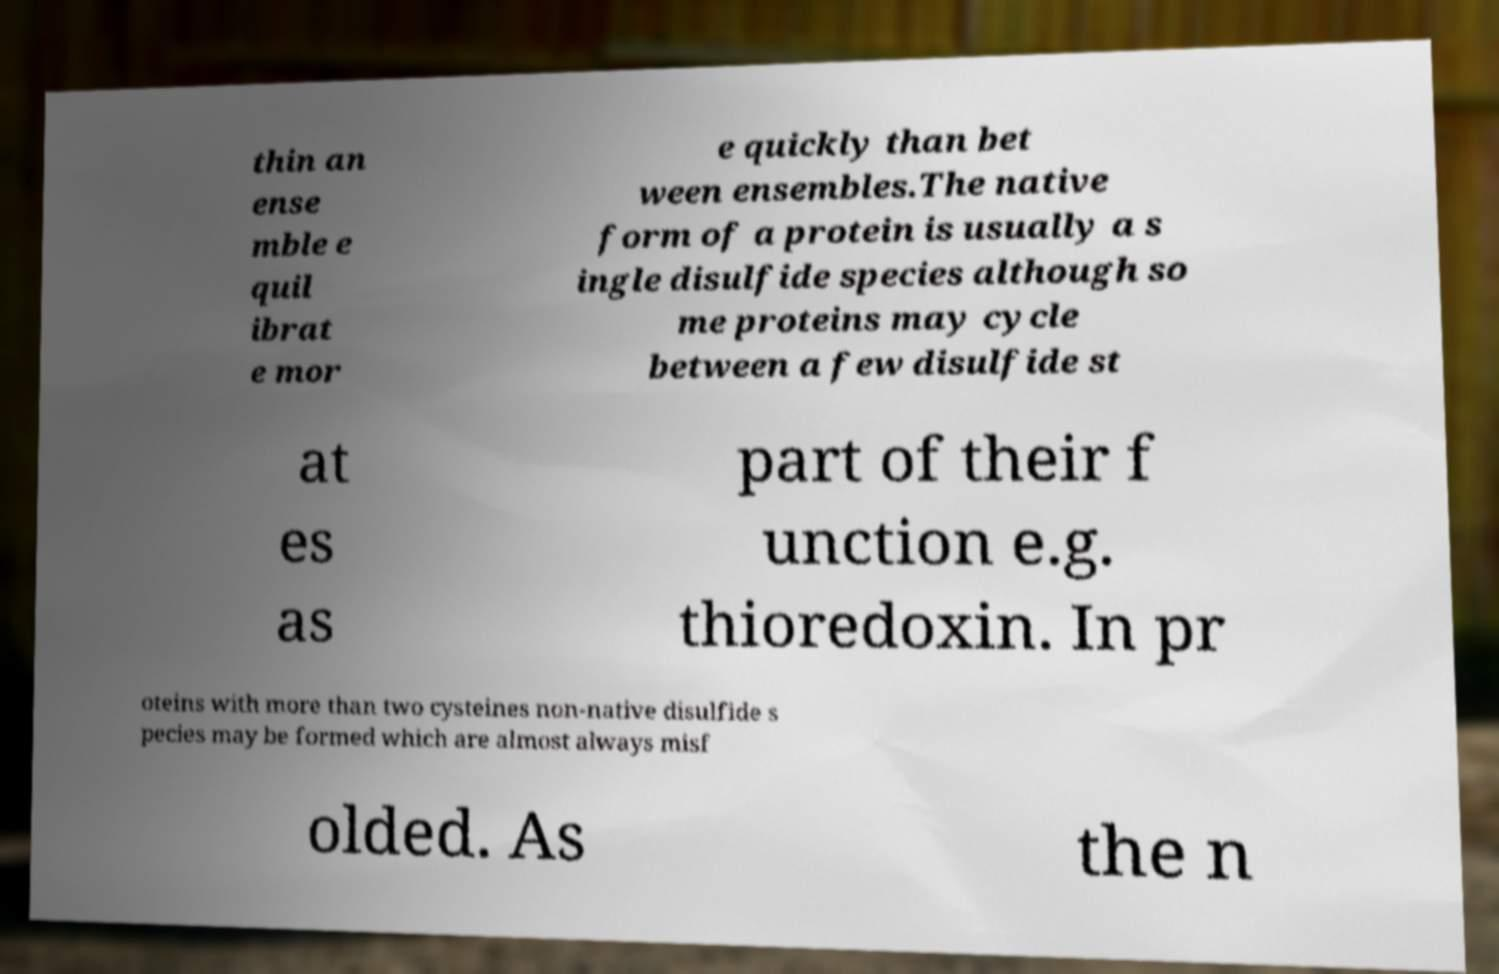I need the written content from this picture converted into text. Can you do that? thin an ense mble e quil ibrat e mor e quickly than bet ween ensembles.The native form of a protein is usually a s ingle disulfide species although so me proteins may cycle between a few disulfide st at es as part of their f unction e.g. thioredoxin. In pr oteins with more than two cysteines non-native disulfide s pecies may be formed which are almost always misf olded. As the n 